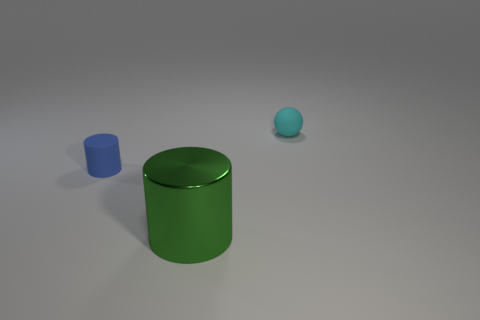What number of rubber balls are the same size as the green object?
Give a very brief answer. 0. Is there a green metal cylinder that is in front of the thing to the right of the big cylinder?
Offer a terse response. Yes. What number of cyan objects are big metal cylinders or small rubber spheres?
Your answer should be compact. 1. The sphere is what color?
Your answer should be very brief. Cyan. The other object that is made of the same material as the tiny cyan object is what size?
Provide a succinct answer. Small. How many other big green metal things have the same shape as the large object?
Ensure brevity in your answer.  0. Is there anything else that is the same size as the green cylinder?
Your response must be concise. No. What size is the matte thing on the right side of the rubber object on the left side of the sphere?
Ensure brevity in your answer.  Small. What is the material of the cylinder that is the same size as the cyan matte thing?
Offer a very short reply. Rubber. Are there any small blue things made of the same material as the small cyan thing?
Keep it short and to the point. Yes. 